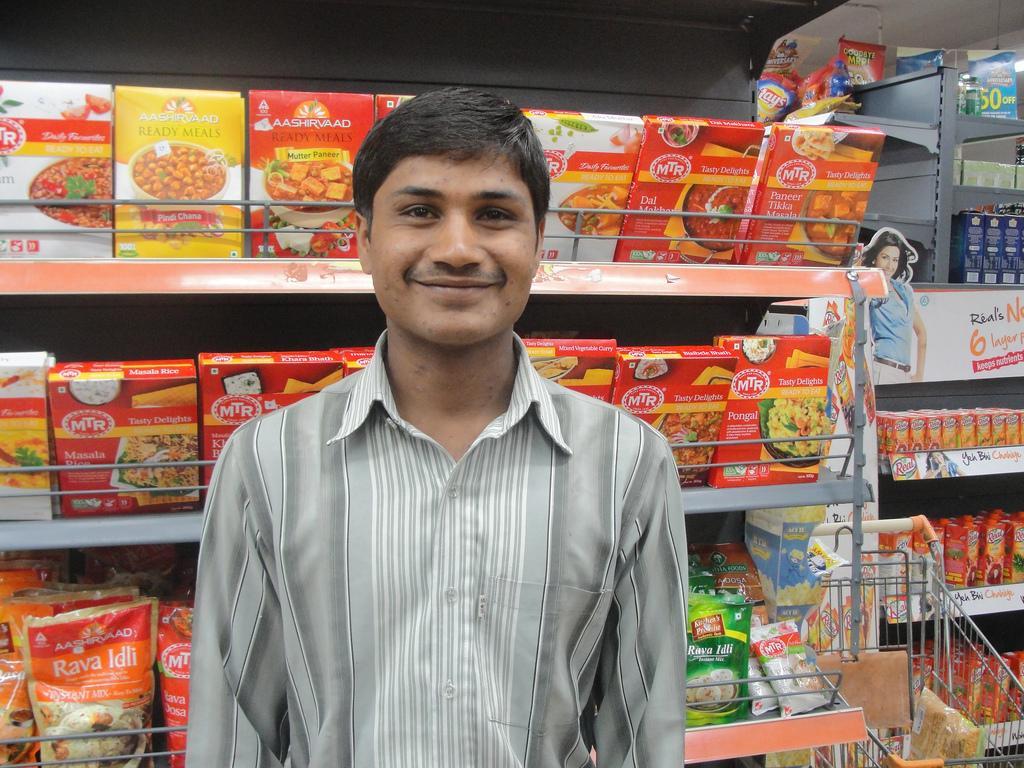Could you give a brief overview of what you see in this image? In this picture there is a man who is standing in the center of the image, there are grocery racks and a trolley in the background area of the image. 